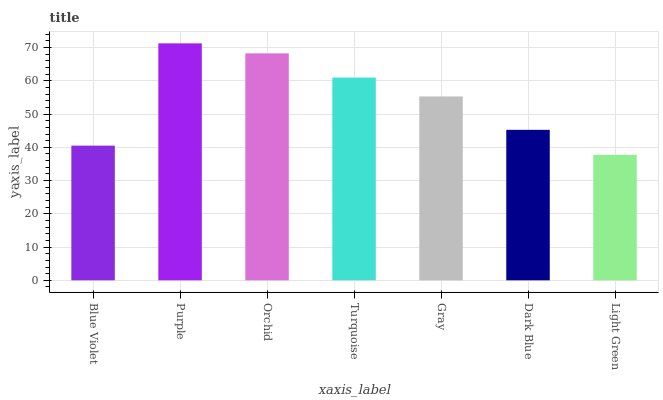Is Light Green the minimum?
Answer yes or no. Yes. Is Purple the maximum?
Answer yes or no. Yes. Is Orchid the minimum?
Answer yes or no. No. Is Orchid the maximum?
Answer yes or no. No. Is Purple greater than Orchid?
Answer yes or no. Yes. Is Orchid less than Purple?
Answer yes or no. Yes. Is Orchid greater than Purple?
Answer yes or no. No. Is Purple less than Orchid?
Answer yes or no. No. Is Gray the high median?
Answer yes or no. Yes. Is Gray the low median?
Answer yes or no. Yes. Is Blue Violet the high median?
Answer yes or no. No. Is Turquoise the low median?
Answer yes or no. No. 